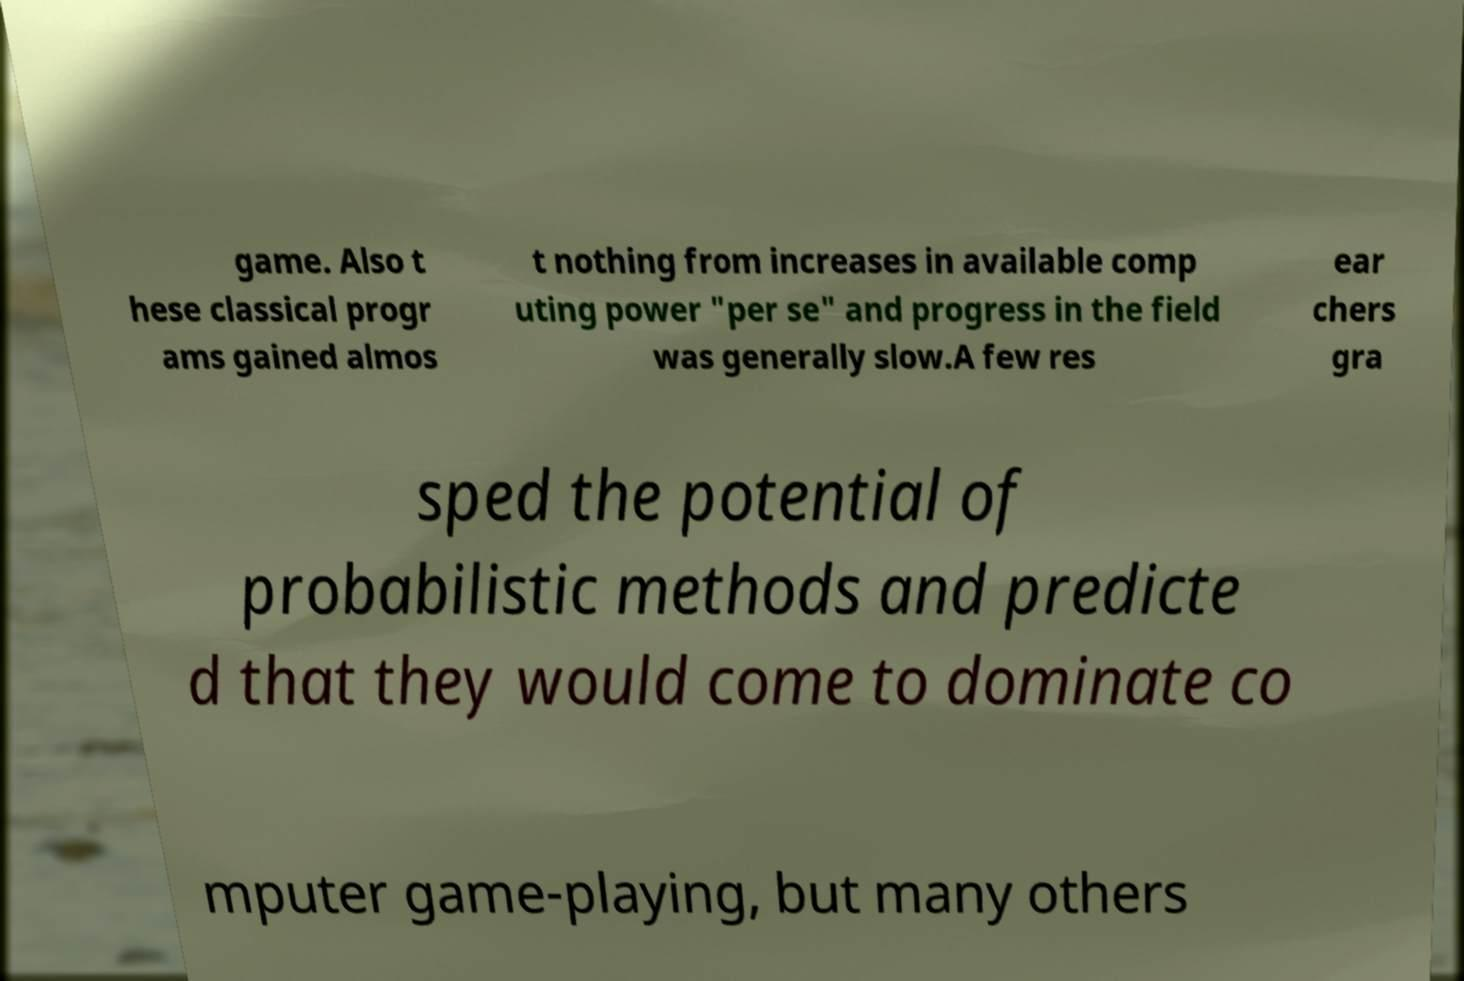Can you read and provide the text displayed in the image?This photo seems to have some interesting text. Can you extract and type it out for me? game. Also t hese classical progr ams gained almos t nothing from increases in available comp uting power "per se" and progress in the field was generally slow.A few res ear chers gra sped the potential of probabilistic methods and predicte d that they would come to dominate co mputer game-playing, but many others 